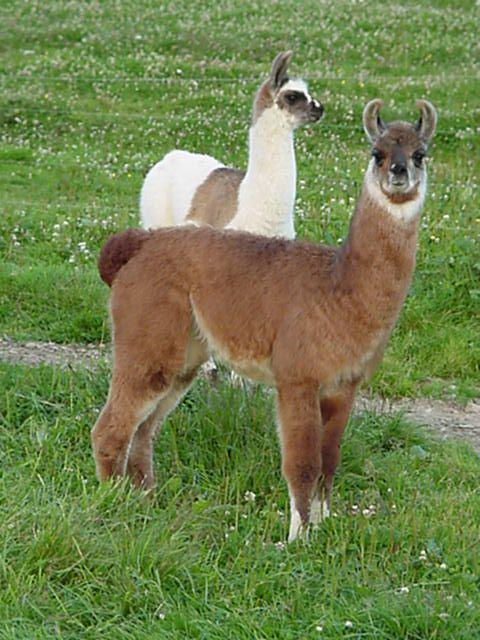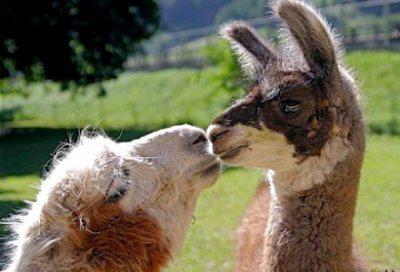The first image is the image on the left, the second image is the image on the right. For the images displayed, is the sentence "In the right image, two dark solid-colored llamas are face-to-face, with their necks stretched." factually correct? Answer yes or no. No. The first image is the image on the left, the second image is the image on the right. Analyze the images presented: Is the assertion "One of the images shows two animals fighting while standing on their hind legs." valid? Answer yes or no. No. 